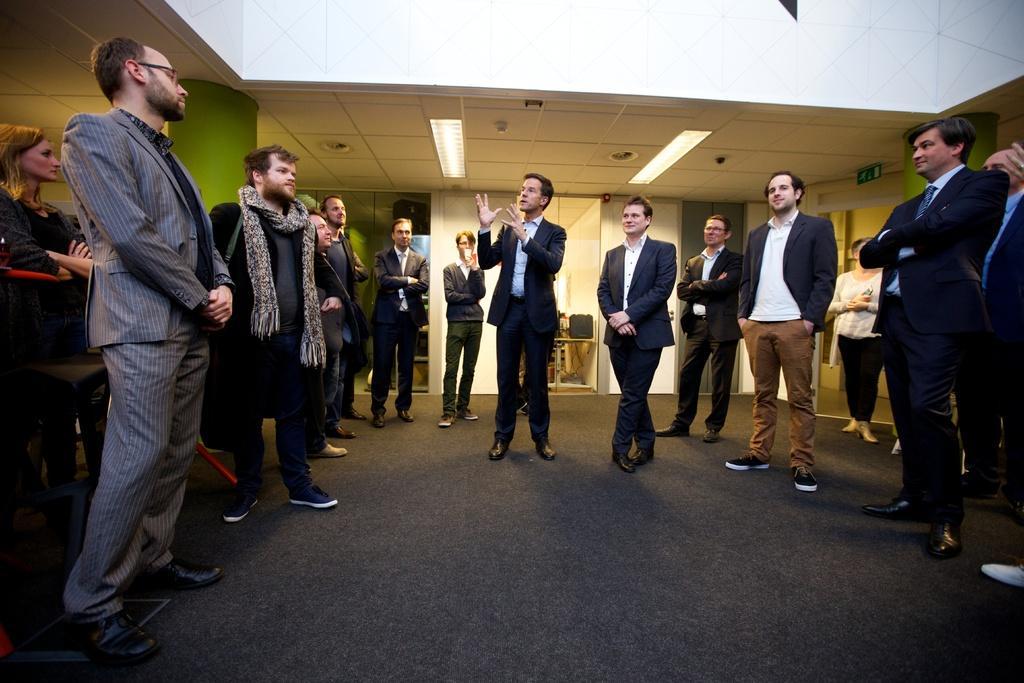Could you give a brief overview of what you see in this image? In this picture I can see group of people standing, there are lights, pillars and in the background there is a wall. 